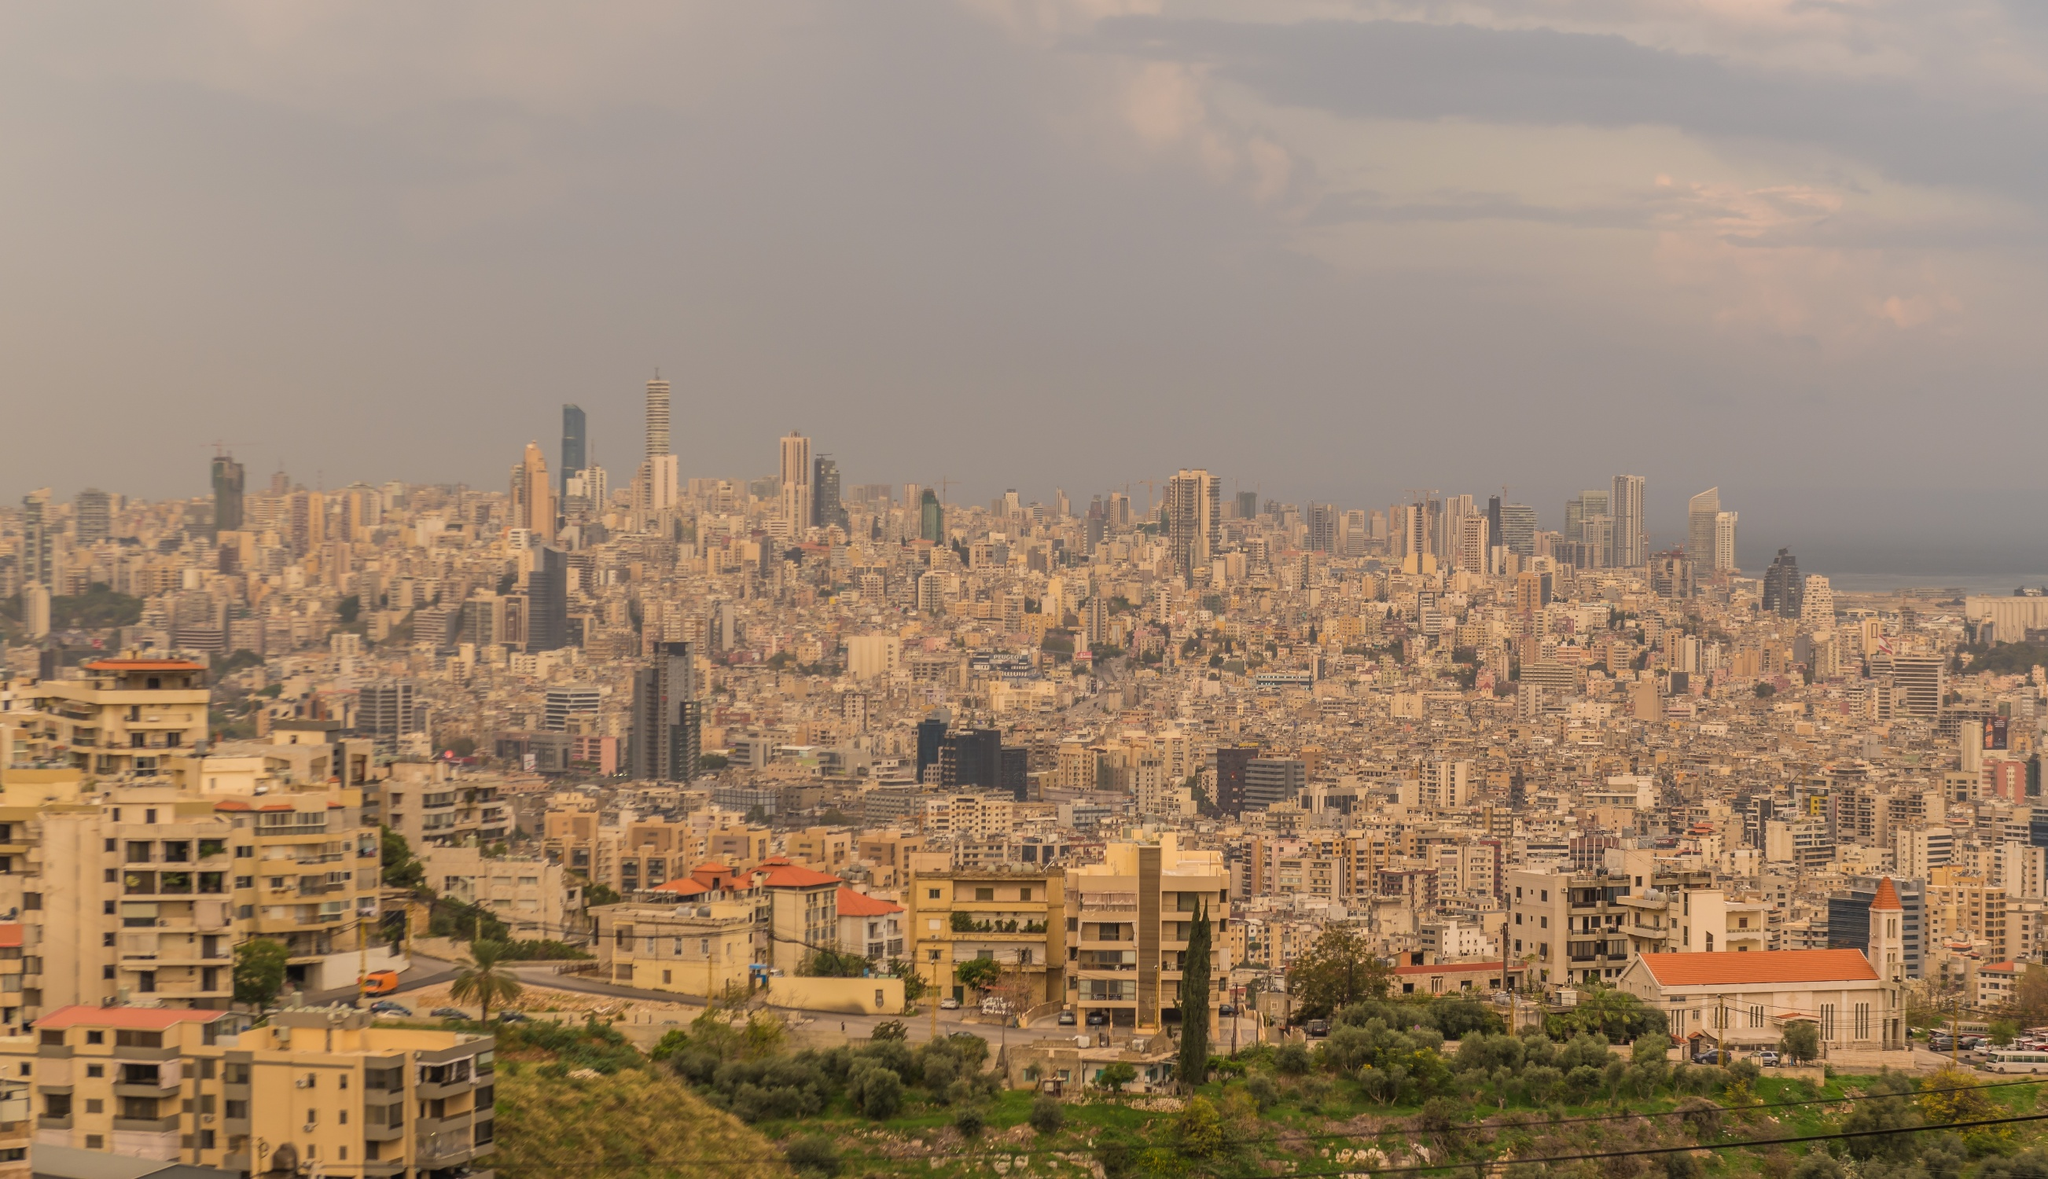What does the variation in building heights and styles tell us about the city? The diversity in building heights and architectural styles in Beirut reflects its rich history and rapid modern development. Lower, older structures hint at the city’s traditional roots, likely remaining from earlier periods. In contrast, towering modern skyscrapers, such as the ones seen in the image, illustrate Beirut's growth and its role as a significant economic center in the region. This mix of old and new encapsulates the city's dynamic history and its resilience through various challenges, including urban and social developments. 